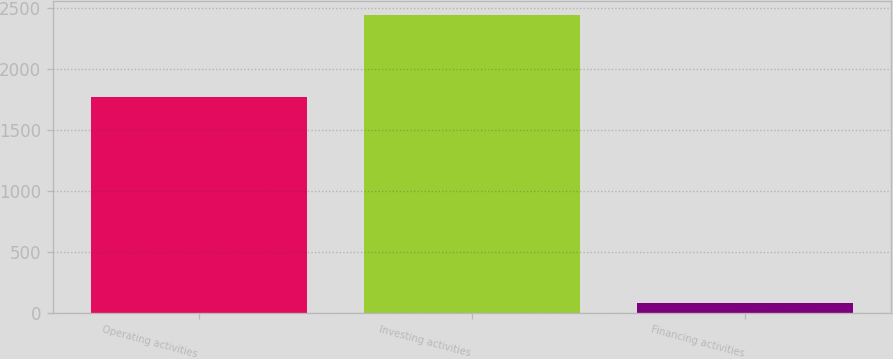Convert chart. <chart><loc_0><loc_0><loc_500><loc_500><bar_chart><fcel>Operating activities<fcel>Investing activities<fcel>Financing activities<nl><fcel>1765.1<fcel>2435.2<fcel>78.4<nl></chart> 